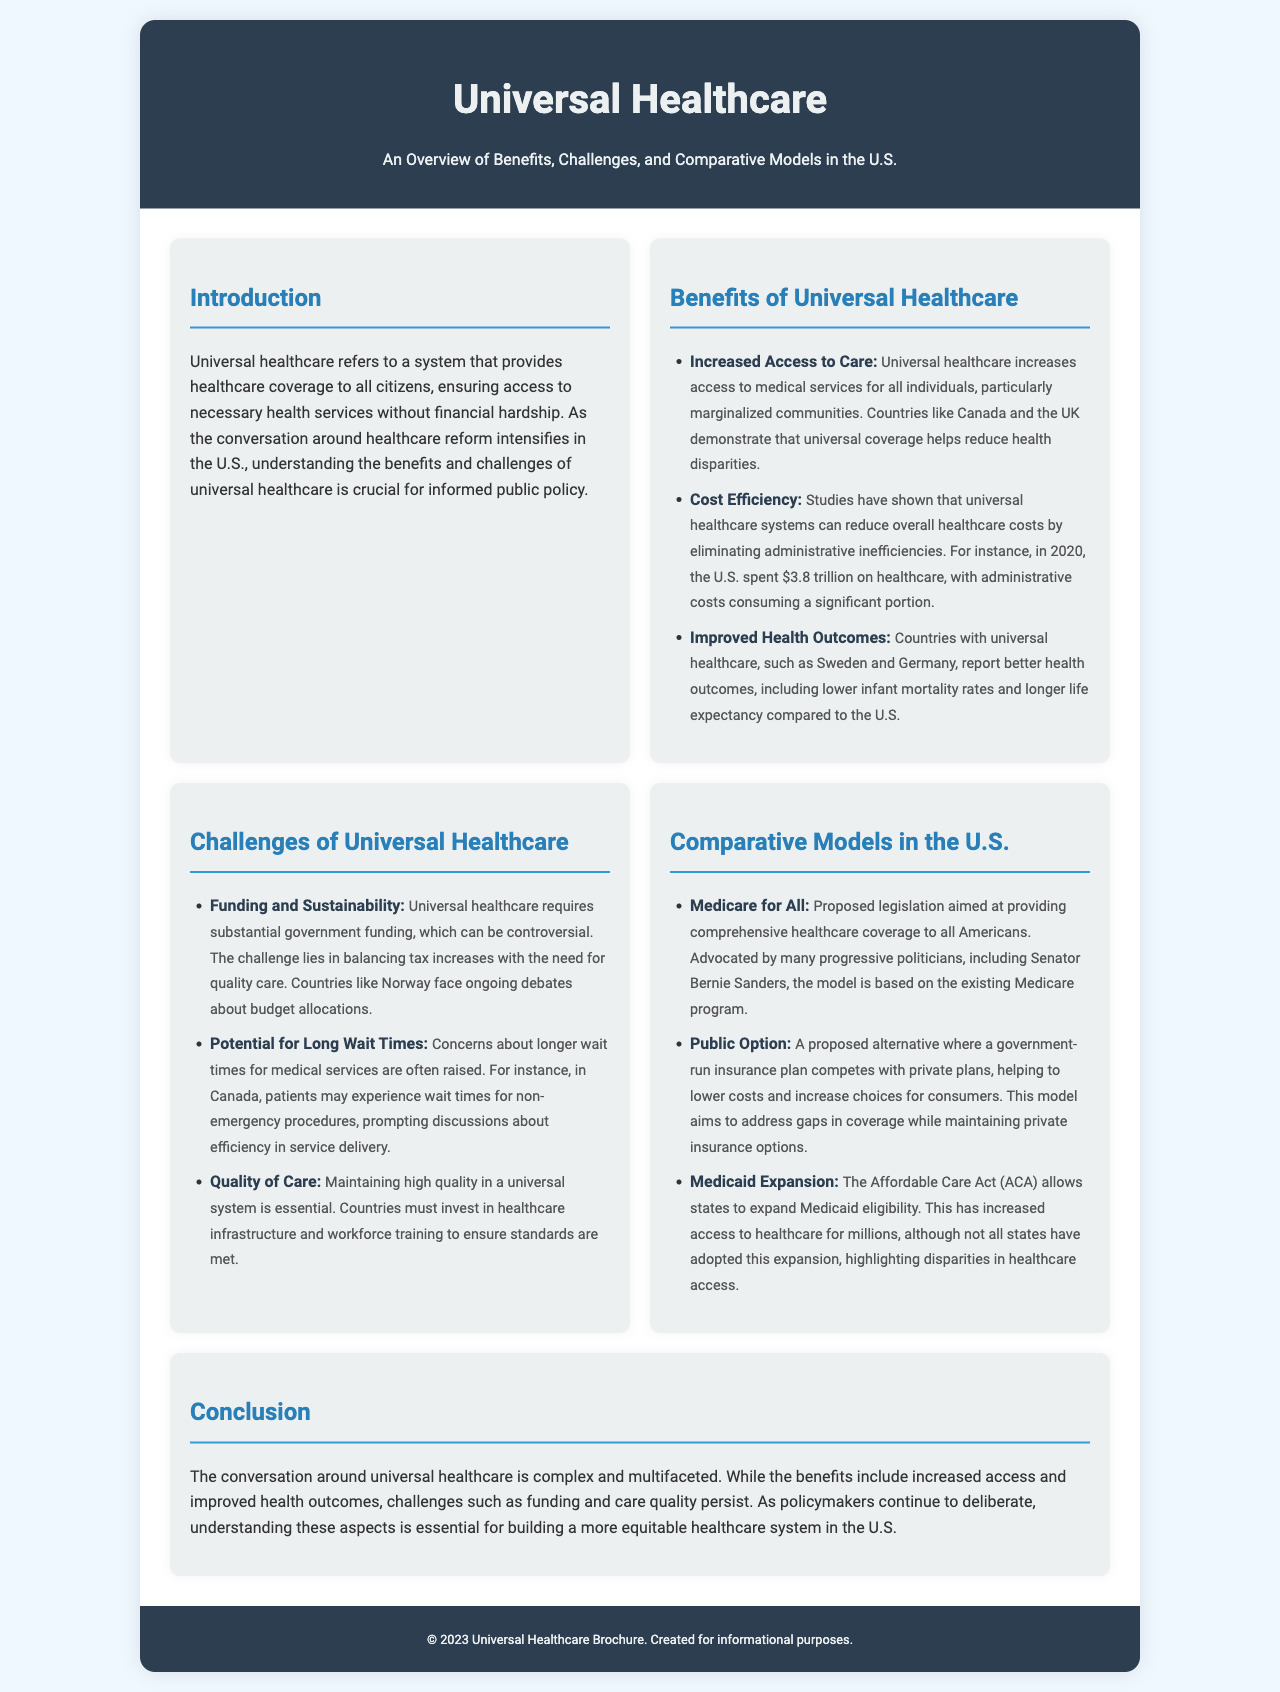What is universal healthcare? Universal healthcare is defined in the introduction as a system that provides healthcare coverage to all citizens, ensuring access to necessary health services without financial hardship.
Answer: a system that provides healthcare coverage to all citizens Which country is mentioned as demonstrating reduced health disparities? Canada is specifically mentioned in the benefits section as a country that helps reduce health disparities through universal coverage.
Answer: Canada What significant portion of U.S. healthcare spending is attributed to administrative costs? The document states that a significant portion of the $3.8 trillion spent on healthcare in the U.S. is attributed to administrative costs.
Answer: a significant portion What is the main concern regarding wait times in universal healthcare systems? The text indicates that concerns about longer wait times for medical services are often raised, particularly in Canada for non-emergency procedures.
Answer: longer wait times Who is a prominent advocate for Medicare for All? Senator Bernie Sanders is mentioned as a prominent advocate for the Medicare for All legislation in the comparative models section.
Answer: Senator Bernie Sanders What is a proposed alternative to universal healthcare mentioned in the brochure? The Public Option is noted as a proposed alternative where a government-run insurance plan competes with private plans.
Answer: Public Option What is one challenge related to funding in universal healthcare? The brochure states that universal healthcare requires substantial government funding, which can be controversial and involves balancing tax increases with the need for quality care.
Answer: substantial government funding What does the Affordable Care Act allow regarding Medicaid? The Affordable Care Act allows states to expand Medicaid eligibility, increasing access to healthcare for millions.
Answer: expand Medicaid eligibility What is a critical aspect for maintaining quality in a universal system? The document emphasizes that maintaining high quality in a universal system requires investment in healthcare infrastructure and workforce training.
Answer: investment in healthcare infrastructure and workforce training 